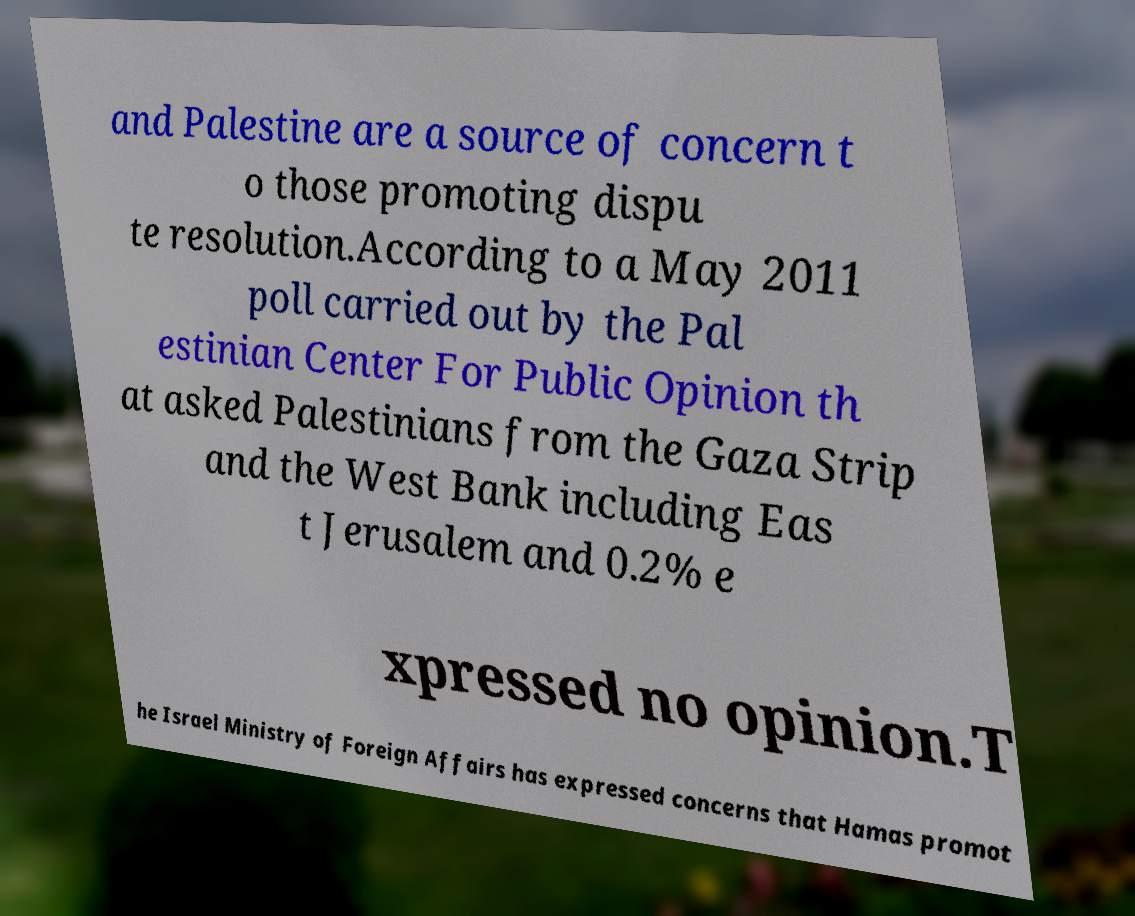Please read and relay the text visible in this image. What does it say? and Palestine are a source of concern t o those promoting dispu te resolution.According to a May 2011 poll carried out by the Pal estinian Center For Public Opinion th at asked Palestinians from the Gaza Strip and the West Bank including Eas t Jerusalem and 0.2% e xpressed no opinion.T he Israel Ministry of Foreign Affairs has expressed concerns that Hamas promot 